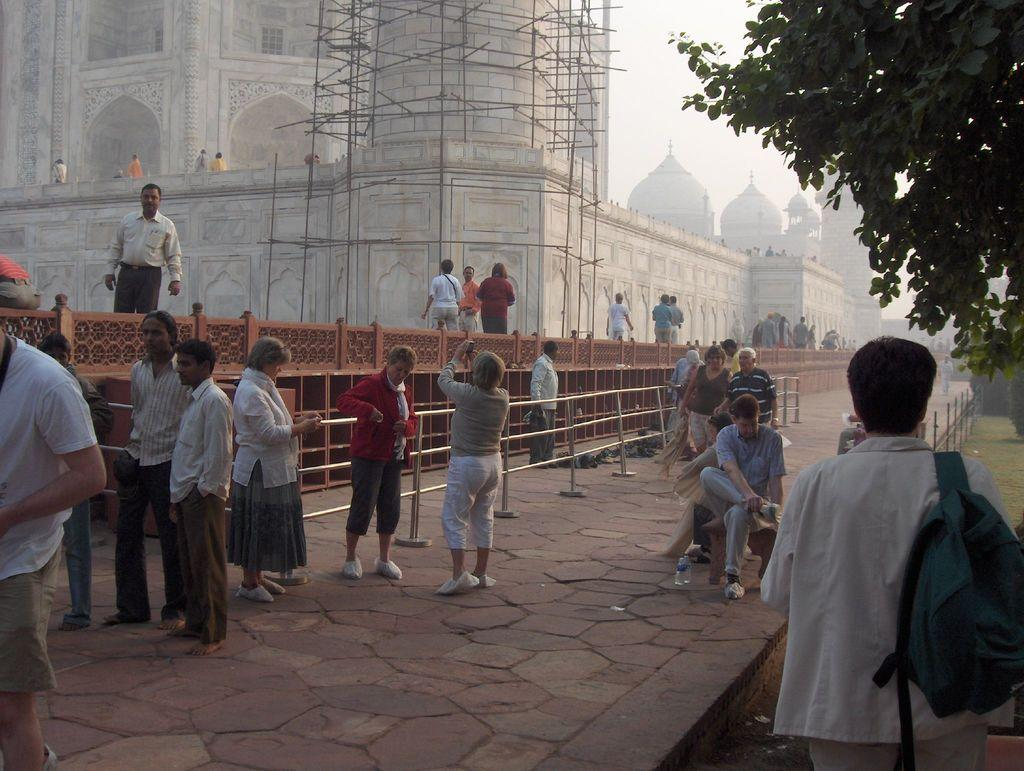How many people are in the image? There is a group of people in the image, but the exact number is not specified. What are some of the people in the image doing? Some people are sitting, and some people are standing. What can be seen in the background of the image? There are buildings and trees in the background of the image. What type of meal is being served in the image? There is no meal present in the image; it features a group of people with some sitting and some standing, along with buildings and trees in the background. How much sugar is visible in the image? There is no sugar visible in the image. 